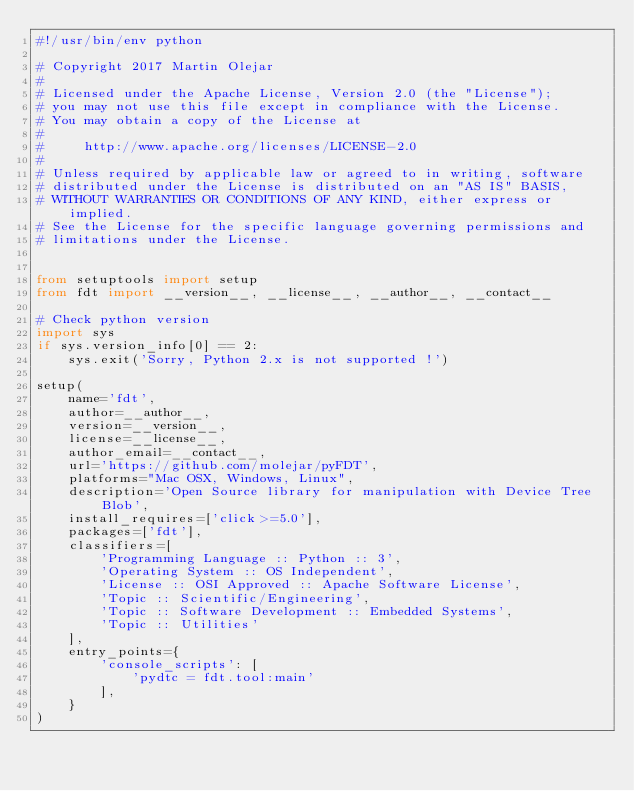<code> <loc_0><loc_0><loc_500><loc_500><_Python_>#!/usr/bin/env python

# Copyright 2017 Martin Olejar
#
# Licensed under the Apache License, Version 2.0 (the "License");
# you may not use this file except in compliance with the License.
# You may obtain a copy of the License at
#
#     http://www.apache.org/licenses/LICENSE-2.0
#
# Unless required by applicable law or agreed to in writing, software
# distributed under the License is distributed on an "AS IS" BASIS,
# WITHOUT WARRANTIES OR CONDITIONS OF ANY KIND, either express or implied.
# See the License for the specific language governing permissions and
# limitations under the License.


from setuptools import setup
from fdt import __version__, __license__, __author__, __contact__

# Check python version
import sys
if sys.version_info[0] == 2:
    sys.exit('Sorry, Python 2.x is not supported !')

setup(
    name='fdt',
    author=__author__,
    version=__version__,
    license=__license__,
    author_email=__contact__,
    url='https://github.com/molejar/pyFDT',
    platforms="Mac OSX, Windows, Linux",
    description='Open Source library for manipulation with Device Tree Blob',
    install_requires=['click>=5.0'],
    packages=['fdt'],
    classifiers=[
        'Programming Language :: Python :: 3',
        'Operating System :: OS Independent',
        'License :: OSI Approved :: Apache Software License',
        'Topic :: Scientific/Engineering',
        'Topic :: Software Development :: Embedded Systems',
        'Topic :: Utilities'
    ],
    entry_points={
        'console_scripts': [
            'pydtc = fdt.tool:main'
        ],
    }
)
</code> 